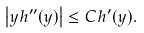<formula> <loc_0><loc_0><loc_500><loc_500>\left | y h ^ { \prime \prime } ( y ) \right | \leq C h ^ { \prime } ( y ) .</formula> 